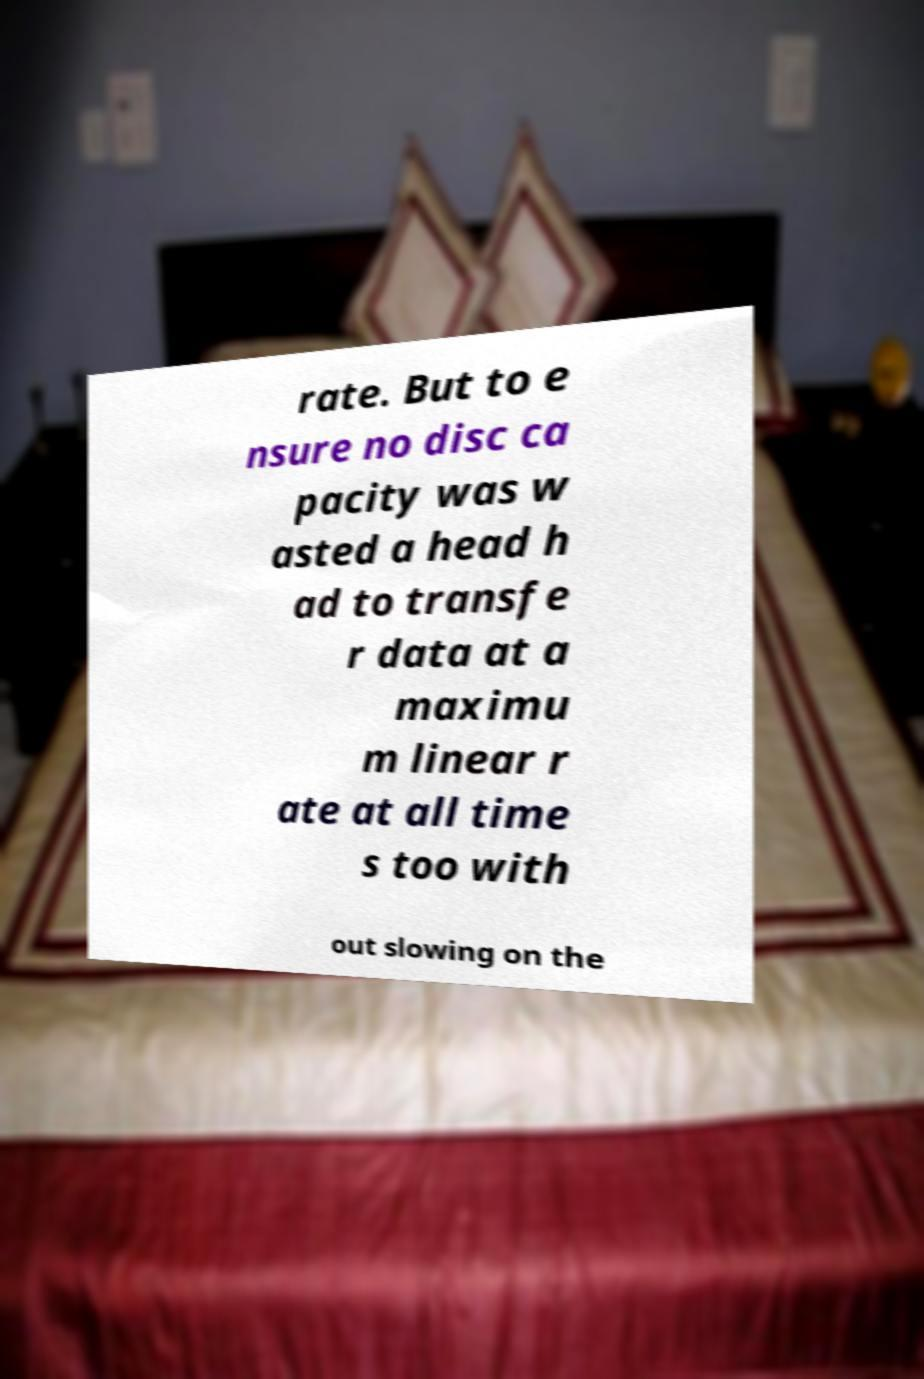I need the written content from this picture converted into text. Can you do that? rate. But to e nsure no disc ca pacity was w asted a head h ad to transfe r data at a maximu m linear r ate at all time s too with out slowing on the 